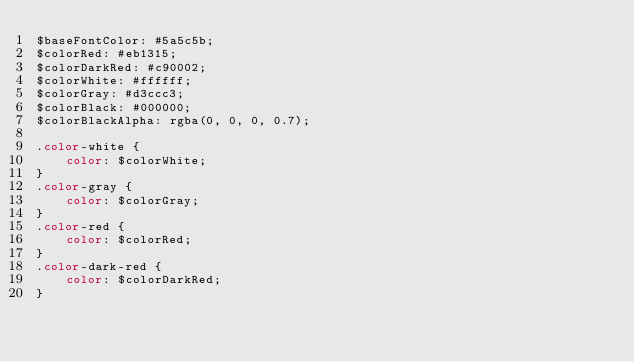Convert code to text. <code><loc_0><loc_0><loc_500><loc_500><_CSS_>$baseFontColor: #5a5c5b;
$colorRed: #eb1315;
$colorDarkRed: #c90002;
$colorWhite: #ffffff;
$colorGray: #d3ccc3;
$colorBlack: #000000;
$colorBlackAlpha: rgba(0, 0, 0, 0.7);

.color-white {
    color: $colorWhite;
}
.color-gray {
    color: $colorGray;
}
.color-red {
    color: $colorRed;
}
.color-dark-red {
    color: $colorDarkRed;
}
</code> 